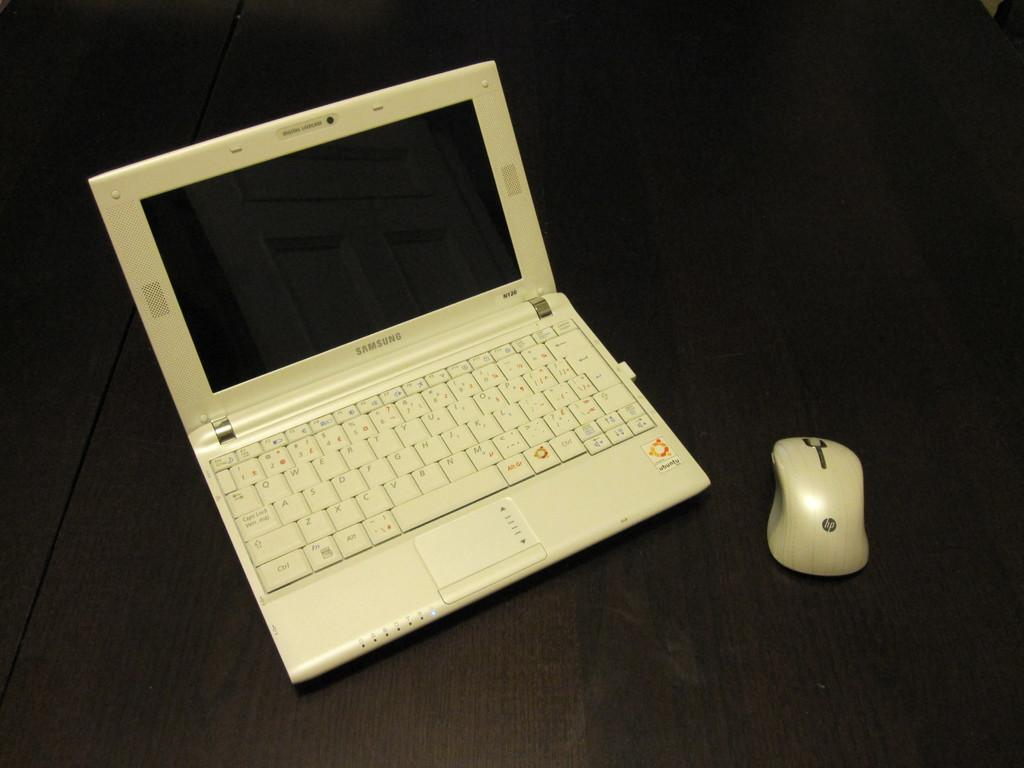What electronic device is visible in the image? There is a laptop in the image. What accessory is present for the laptop? There is a mouse in the image. Where are the laptop and mouse located? The laptop and mouse are placed on a table. Can you see a rabbit playing with the laptop in the image? There is no rabbit present in the image, and the rabbit is not interacting with the laptop. 